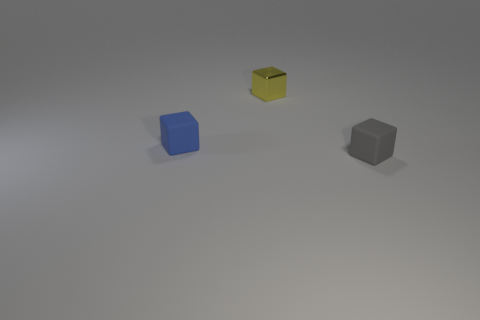Add 1 rubber cubes. How many objects exist? 4 Subtract 0 brown cylinders. How many objects are left? 3 Subtract all yellow metallic cubes. Subtract all tiny yellow things. How many objects are left? 1 Add 1 tiny gray rubber cubes. How many tiny gray rubber cubes are left? 2 Add 3 gray things. How many gray things exist? 4 